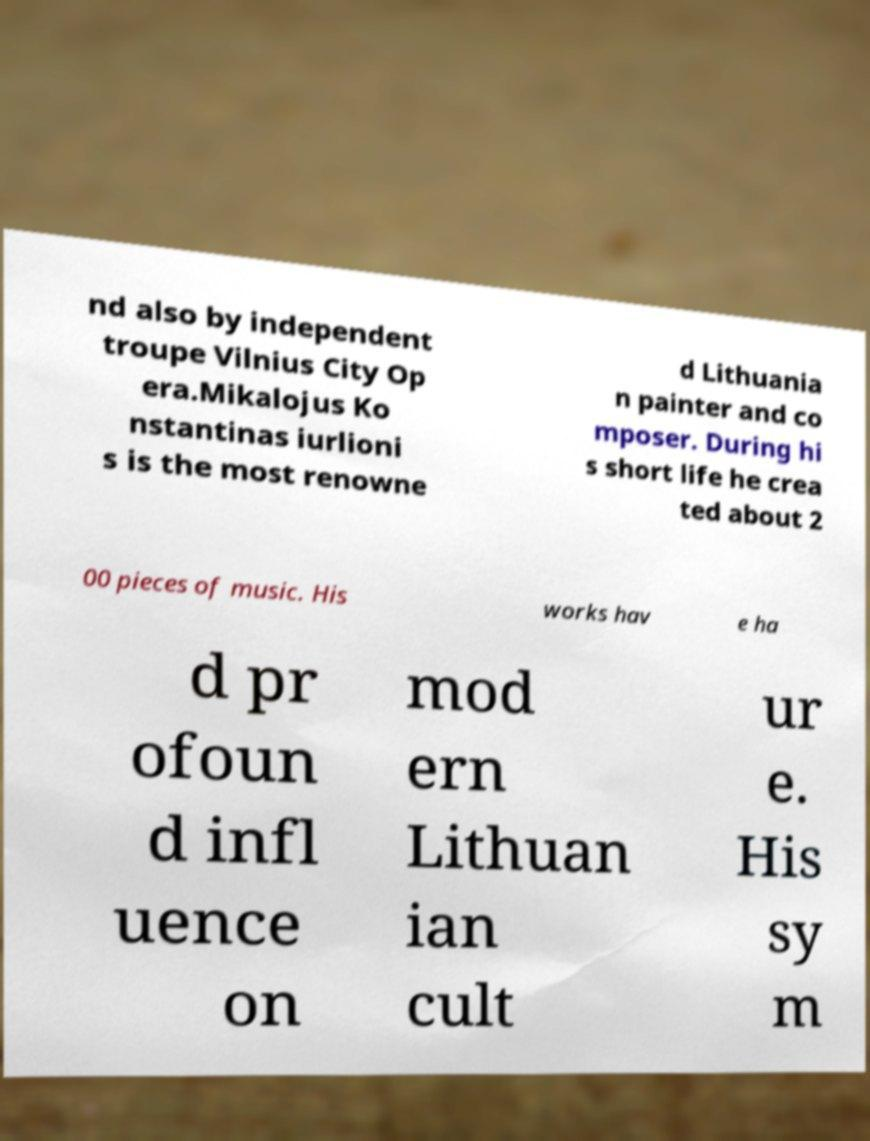Please read and relay the text visible in this image. What does it say? nd also by independent troupe Vilnius City Op era.Mikalojus Ko nstantinas iurlioni s is the most renowne d Lithuania n painter and co mposer. During hi s short life he crea ted about 2 00 pieces of music. His works hav e ha d pr ofoun d infl uence on mod ern Lithuan ian cult ur e. His sy m 